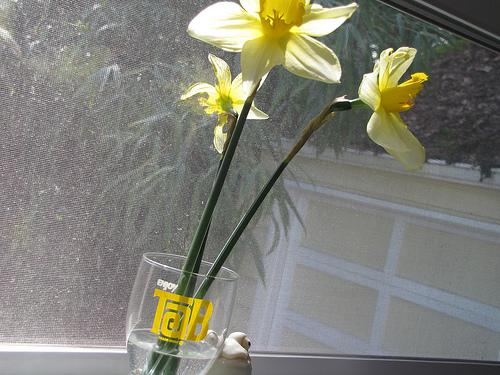Question: why is there water in the glass?
Choices:
A. To drink.
B. To clean.
C. To keep the flowers pretty.
D. For effect.
Answer with the letter. Answer: C Question: what kind of flowers are these?
Choices:
A. Roses.
B. Daffodils.
C. Violets.
D. Orchids.
Answer with the letter. Answer: B Question: what color are the flowers?
Choices:
A. Red.
B. Yellow.
C. Purple.
D. White.
Answer with the letter. Answer: B Question: how many flowers are in the glass?
Choices:
A. Three.
B. Twelve.
C. Six.
D. Nine.
Answer with the letter. Answer: A Question: when was this photo taken?
Choices:
A. During the night.
B. At noon.
C. At dawn.
D. During the daytime.
Answer with the letter. Answer: D Question: what are the flowers sitting in front of?
Choices:
A. A wall.
B. A chair.
C. A window.
D. A lamp.
Answer with the letter. Answer: C 